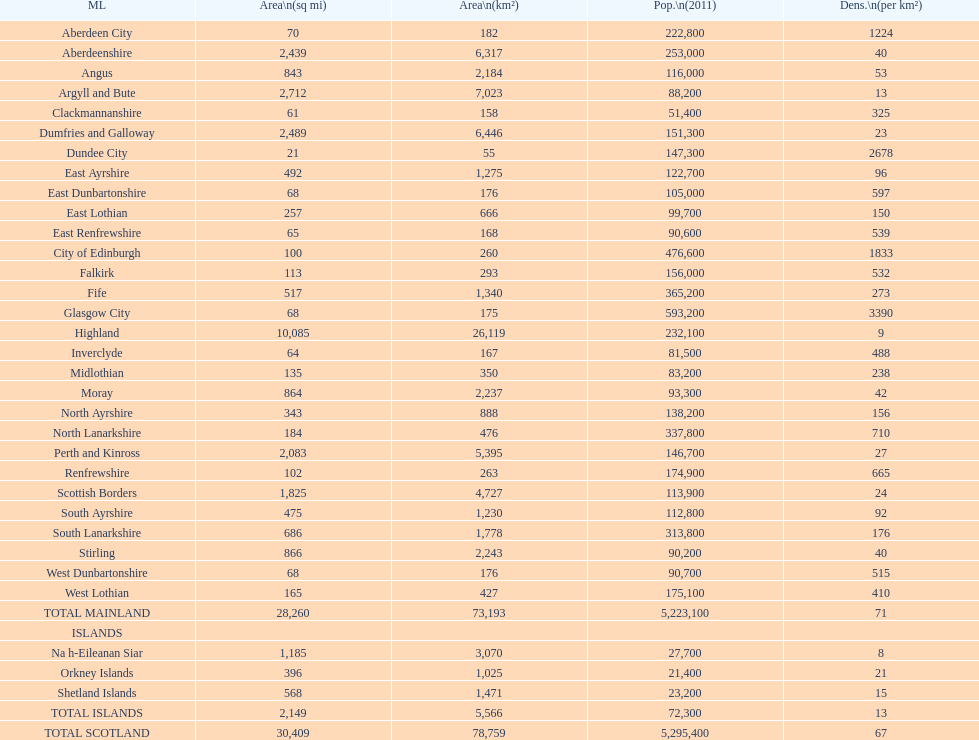Which mainland has the least population? Clackmannanshire. 